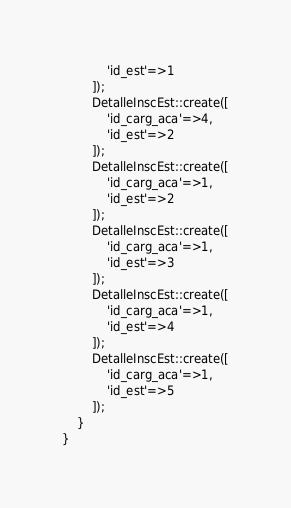Convert code to text. <code><loc_0><loc_0><loc_500><loc_500><_PHP_>        	'id_est'=>1
        ]);
        DetalleInscEst::create([
        	'id_carg_aca'=>4,
        	'id_est'=>2
        ]);
        DetalleInscEst::create([
        	'id_carg_aca'=>1,
        	'id_est'=>2
        ]);
        DetalleInscEst::create([
            'id_carg_aca'=>1,
            'id_est'=>3
        ]);
        DetalleInscEst::create([
            'id_carg_aca'=>1,
            'id_est'=>4
        ]);
        DetalleInscEst::create([
            'id_carg_aca'=>1,
            'id_est'=>5
        ]);
    }
}
</code> 